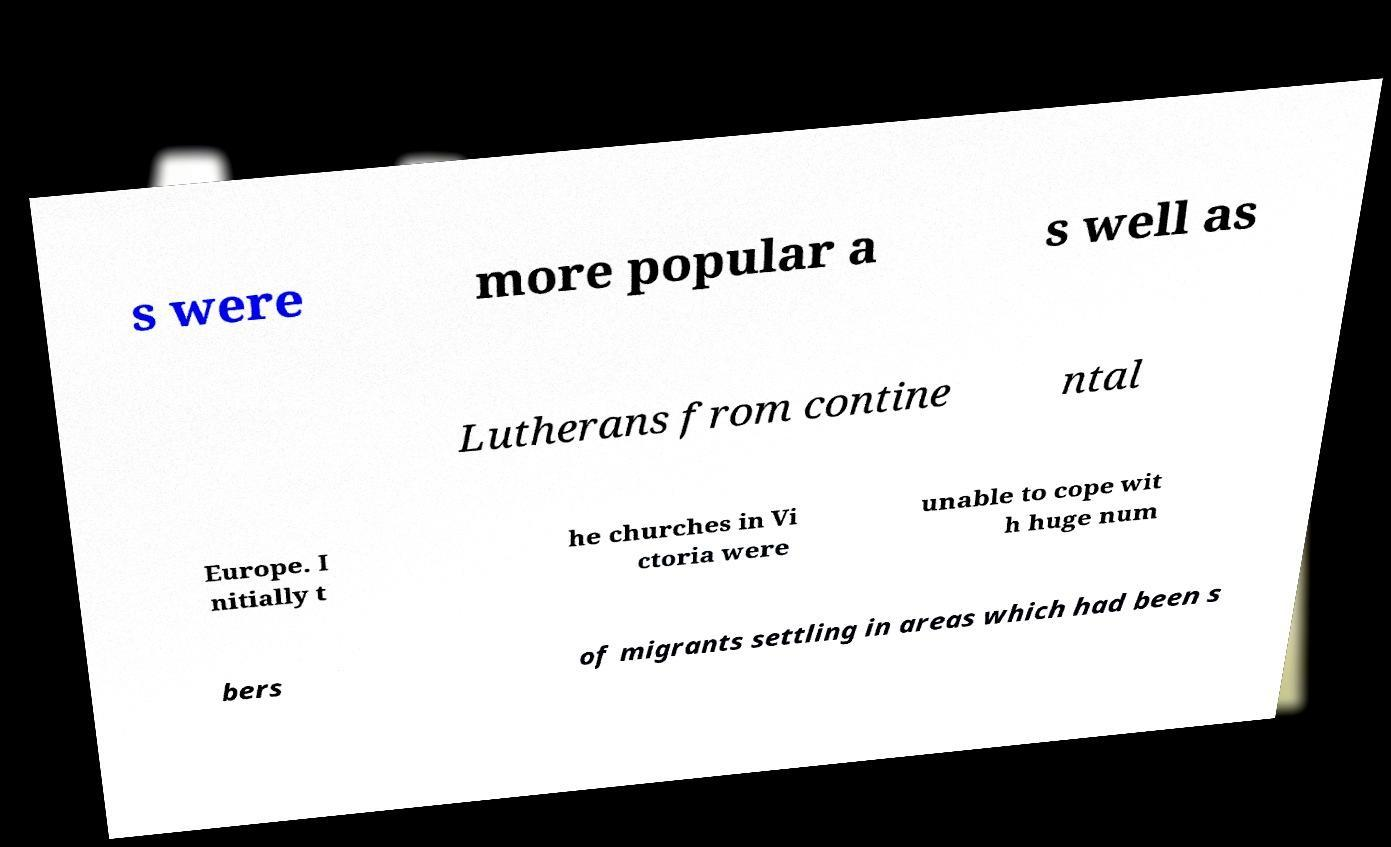Please identify and transcribe the text found in this image. s were more popular a s well as Lutherans from contine ntal Europe. I nitially t he churches in Vi ctoria were unable to cope wit h huge num bers of migrants settling in areas which had been s 